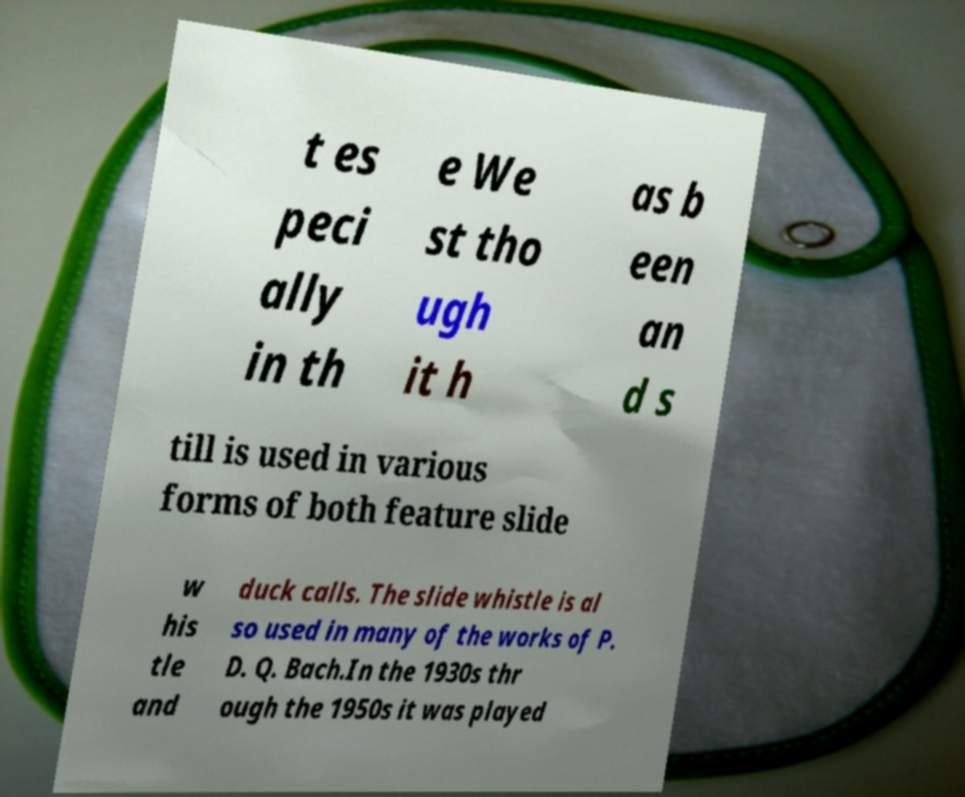What messages or text are displayed in this image? I need them in a readable, typed format. t es peci ally in th e We st tho ugh it h as b een an d s till is used in various forms of both feature slide w his tle and duck calls. The slide whistle is al so used in many of the works of P. D. Q. Bach.In the 1930s thr ough the 1950s it was played 